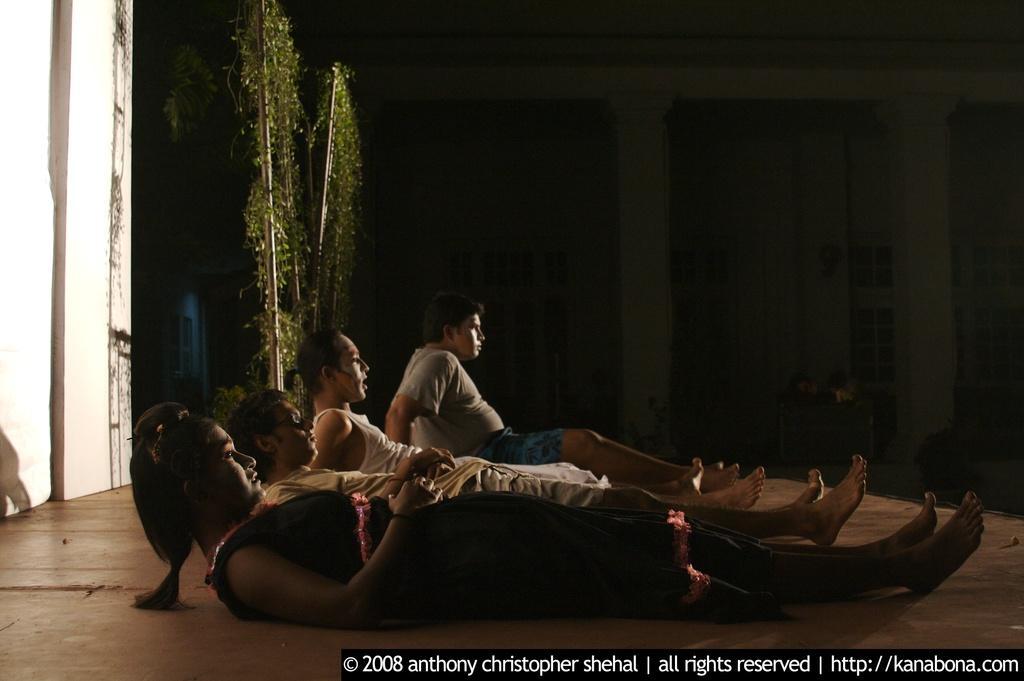How would you summarize this image in a sentence or two? In this image I can see four people with different color dresses. These people are on the brown color surface. In the back I can see the plants and the building. I can also see the watermark in the image. 